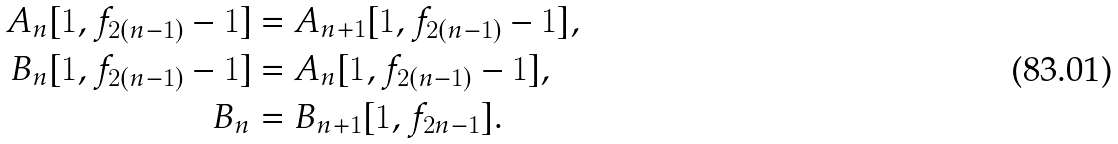<formula> <loc_0><loc_0><loc_500><loc_500>A _ { n } [ 1 , f _ { 2 ( n - 1 ) } - 1 ] & = A _ { n + 1 } [ 1 , f _ { 2 ( n - 1 ) } - 1 ] , \\ B _ { n } [ 1 , f _ { 2 ( n - 1 ) } - 1 ] & = A _ { n } [ 1 , f _ { 2 ( n - 1 ) } - 1 ] , \\ B _ { n } & = B _ { n + 1 } [ 1 , f _ { 2 n - 1 } ] .</formula> 